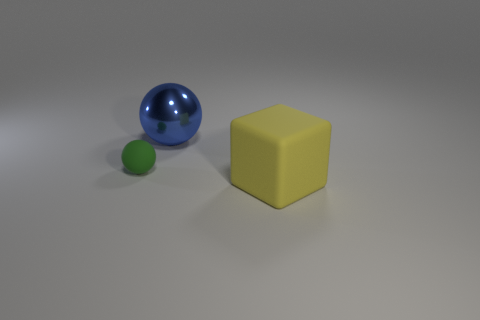There is another object that is the same shape as the small green thing; what is its color?
Give a very brief answer. Blue. There is a object that is in front of the object that is left of the blue metallic thing; what is it made of?
Provide a short and direct response. Rubber. Are there more metallic objects that are to the right of the green matte object than large blue objects behind the blue thing?
Provide a short and direct response. Yes. What size is the matte sphere?
Your answer should be very brief. Small. Is there anything else that is the same shape as the green matte object?
Provide a succinct answer. Yes. There is a object behind the small rubber thing; are there any objects that are to the left of it?
Make the answer very short. Yes. Are there fewer tiny matte spheres to the right of the green ball than green spheres that are left of the large shiny thing?
Your answer should be very brief. Yes. There is a ball that is in front of the sphere that is behind the ball on the left side of the metal ball; how big is it?
Give a very brief answer. Small. There is a rubber thing that is left of the blue sphere; is it the same size as the metallic object?
Make the answer very short. No. What number of other things are made of the same material as the green object?
Your answer should be compact. 1. 